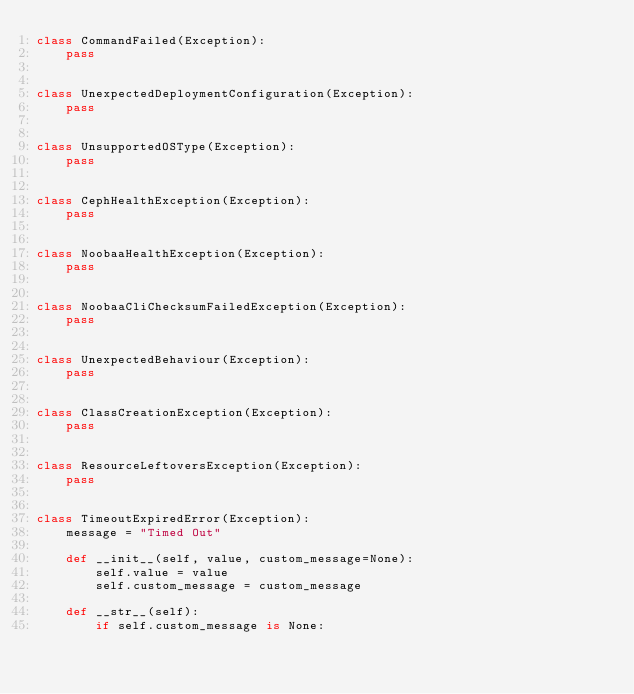<code> <loc_0><loc_0><loc_500><loc_500><_Python_>class CommandFailed(Exception):
    pass


class UnexpectedDeploymentConfiguration(Exception):
    pass


class UnsupportedOSType(Exception):
    pass


class CephHealthException(Exception):
    pass


class NoobaaHealthException(Exception):
    pass


class NoobaaCliChecksumFailedException(Exception):
    pass


class UnexpectedBehaviour(Exception):
    pass


class ClassCreationException(Exception):
    pass


class ResourceLeftoversException(Exception):
    pass


class TimeoutExpiredError(Exception):
    message = "Timed Out"

    def __init__(self, value, custom_message=None):
        self.value = value
        self.custom_message = custom_message

    def __str__(self):
        if self.custom_message is None:</code> 